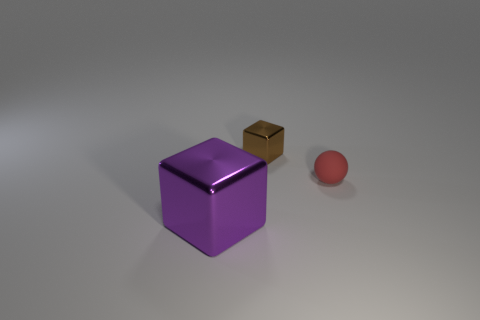Are the tiny thing that is in front of the brown shiny cube and the tiny brown thing made of the same material?
Your answer should be compact. No. Is there a small metal thing that has the same color as the tiny rubber ball?
Ensure brevity in your answer.  No. What is the shape of the big shiny object?
Make the answer very short. Cube. What is the color of the metal cube that is in front of the thing that is on the right side of the tiny brown thing?
Provide a short and direct response. Purple. There is a shiny cube that is in front of the matte thing; how big is it?
Your answer should be very brief. Large. Is there a thing made of the same material as the red sphere?
Ensure brevity in your answer.  No. How many other objects have the same shape as the big purple object?
Your answer should be very brief. 1. There is a tiny thing behind the small thing that is to the right of the cube that is behind the big shiny block; what is its shape?
Offer a terse response. Cube. There is a thing that is both in front of the small brown block and right of the purple block; what is its material?
Make the answer very short. Rubber. There is a cube that is in front of the red matte object; is its size the same as the small brown metallic cube?
Provide a succinct answer. No. 